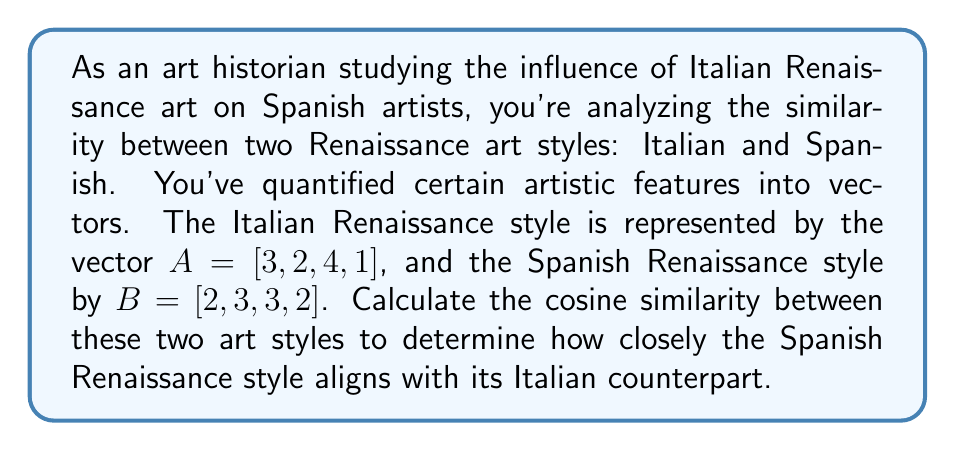Solve this math problem. To calculate the cosine similarity between two vectors, we use the formula:

$$\text{Cosine Similarity} = \frac{A \cdot B}{\|A\| \|B\|}$$

Where $A \cdot B$ is the dot product of the vectors, and $\|A\|$ and $\|B\|$ are the magnitudes of vectors $A$ and $B$ respectively.

Step 1: Calculate the dot product $A \cdot B$
$A \cdot B = (3 \times 2) + (2 \times 3) + (4 \times 3) + (1 \times 2) = 6 + 6 + 12 + 2 = 26$

Step 2: Calculate $\|A\|$
$\|A\| = \sqrt{3^2 + 2^2 + 4^2 + 1^2} = \sqrt{9 + 4 + 16 + 1} = \sqrt{30}$

Step 3: Calculate $\|B\|$
$\|B\| = \sqrt{2^2 + 3^2 + 3^2 + 2^2} = \sqrt{4 + 9 + 9 + 4} = \sqrt{26}$

Step 4: Apply the cosine similarity formula
$$\text{Cosine Similarity} = \frac{26}{\sqrt{30} \times \sqrt{26}}$$

Step 5: Simplify and calculate the final result
$$\text{Cosine Similarity} = \frac{26}{\sqrt{780}} \approx 0.9315$$
Answer: The cosine similarity between the Italian and Spanish Renaissance art styles is approximately 0.9315. 